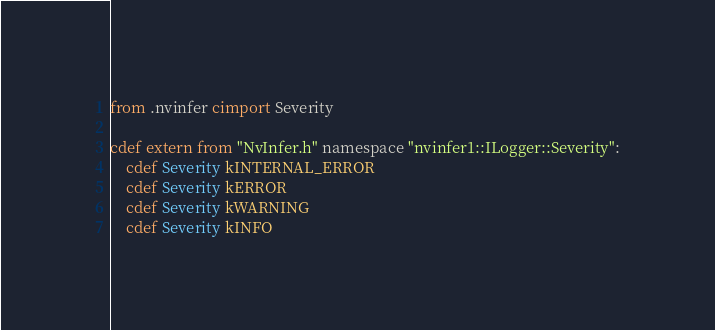Convert code to text. <code><loc_0><loc_0><loc_500><loc_500><_Cython_>from .nvinfer cimport Severity

cdef extern from "NvInfer.h" namespace "nvinfer1::ILogger::Severity":
    cdef Severity kINTERNAL_ERROR
    cdef Severity kERROR
    cdef Severity kWARNING
    cdef Severity kINFO
</code> 